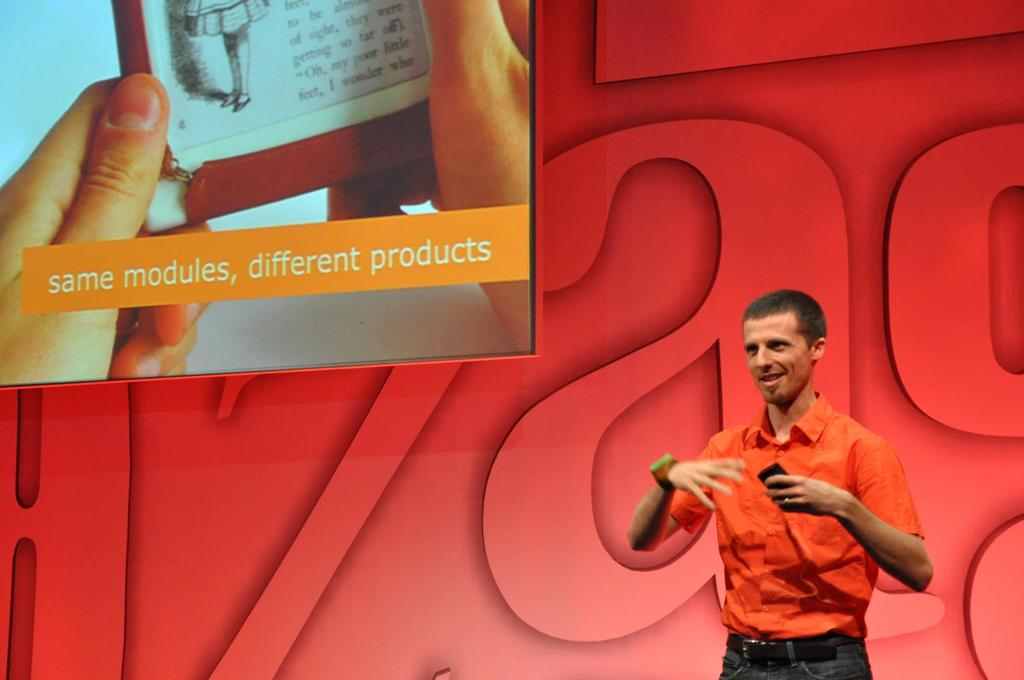How would you describe the audience's reaction to the presentation? Although the audience is not visible in the image, the speaker's confident body language and the clarity of the message conveyed suggest that the presentation is well-received, likely engaging and informative. 